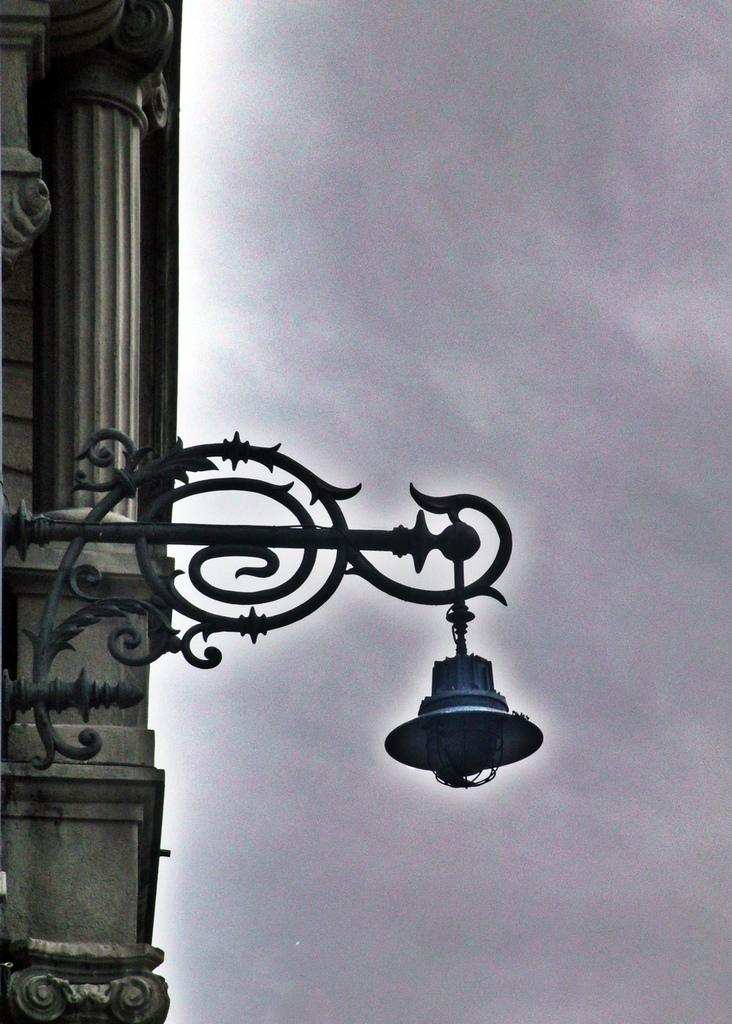What is the main object in the image? There is a street light in the image. What is located behind the street light? There is a pillar behind the street light. How would you describe the sky in the image? The sky is cloudy in the image. How many pairs of shoes can be seen on the pillar in the image? There are no shoes present in the image, so it is not possible to determine the number of pairs. 